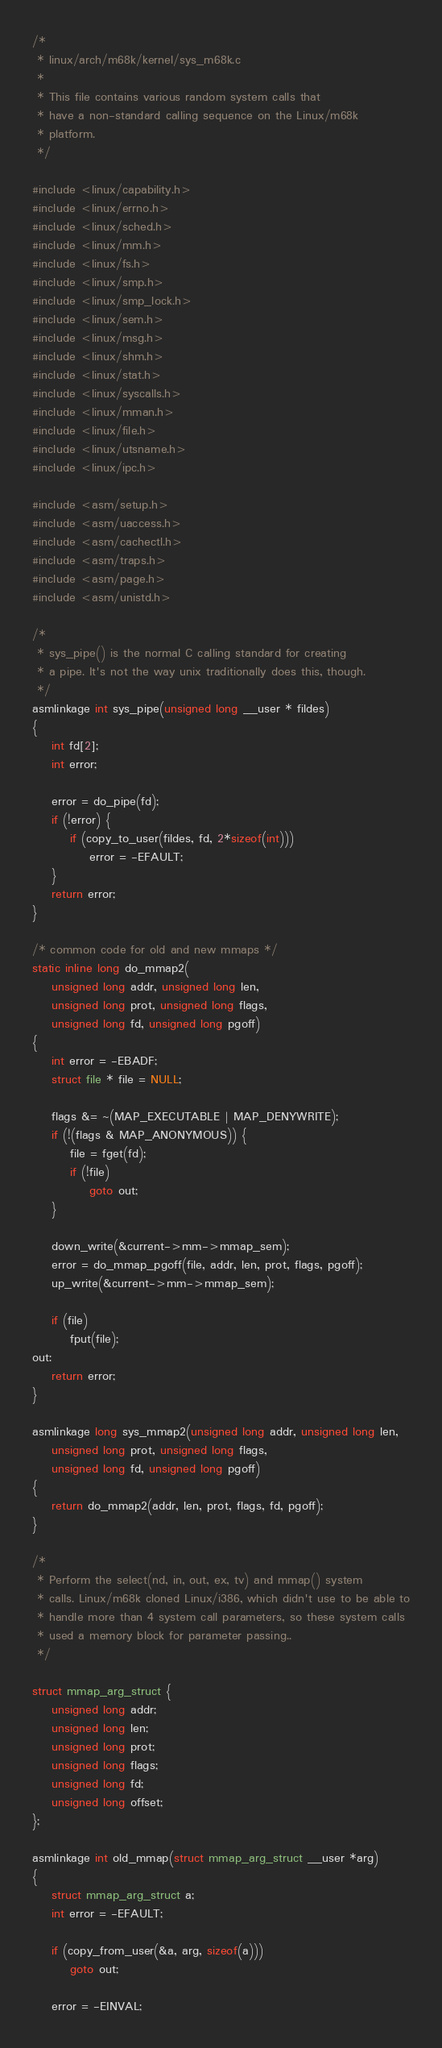Convert code to text. <code><loc_0><loc_0><loc_500><loc_500><_C_>/*
 * linux/arch/m68k/kernel/sys_m68k.c
 *
 * This file contains various random system calls that
 * have a non-standard calling sequence on the Linux/m68k
 * platform.
 */

#include <linux/capability.h>
#include <linux/errno.h>
#include <linux/sched.h>
#include <linux/mm.h>
#include <linux/fs.h>
#include <linux/smp.h>
#include <linux/smp_lock.h>
#include <linux/sem.h>
#include <linux/msg.h>
#include <linux/shm.h>
#include <linux/stat.h>
#include <linux/syscalls.h>
#include <linux/mman.h>
#include <linux/file.h>
#include <linux/utsname.h>
#include <linux/ipc.h>

#include <asm/setup.h>
#include <asm/uaccess.h>
#include <asm/cachectl.h>
#include <asm/traps.h>
#include <asm/page.h>
#include <asm/unistd.h>

/*
 * sys_pipe() is the normal C calling standard for creating
 * a pipe. It's not the way unix traditionally does this, though.
 */
asmlinkage int sys_pipe(unsigned long __user * fildes)
{
	int fd[2];
	int error;

	error = do_pipe(fd);
	if (!error) {
		if (copy_to_user(fildes, fd, 2*sizeof(int)))
			error = -EFAULT;
	}
	return error;
}

/* common code for old and new mmaps */
static inline long do_mmap2(
	unsigned long addr, unsigned long len,
	unsigned long prot, unsigned long flags,
	unsigned long fd, unsigned long pgoff)
{
	int error = -EBADF;
	struct file * file = NULL;

	flags &= ~(MAP_EXECUTABLE | MAP_DENYWRITE);
	if (!(flags & MAP_ANONYMOUS)) {
		file = fget(fd);
		if (!file)
			goto out;
	}

	down_write(&current->mm->mmap_sem);
	error = do_mmap_pgoff(file, addr, len, prot, flags, pgoff);
	up_write(&current->mm->mmap_sem);

	if (file)
		fput(file);
out:
	return error;
}

asmlinkage long sys_mmap2(unsigned long addr, unsigned long len,
	unsigned long prot, unsigned long flags,
	unsigned long fd, unsigned long pgoff)
{
	return do_mmap2(addr, len, prot, flags, fd, pgoff);
}

/*
 * Perform the select(nd, in, out, ex, tv) and mmap() system
 * calls. Linux/m68k cloned Linux/i386, which didn't use to be able to
 * handle more than 4 system call parameters, so these system calls
 * used a memory block for parameter passing..
 */

struct mmap_arg_struct {
	unsigned long addr;
	unsigned long len;
	unsigned long prot;
	unsigned long flags;
	unsigned long fd;
	unsigned long offset;
};

asmlinkage int old_mmap(struct mmap_arg_struct __user *arg)
{
	struct mmap_arg_struct a;
	int error = -EFAULT;

	if (copy_from_user(&a, arg, sizeof(a)))
		goto out;

	error = -EINVAL;</code> 